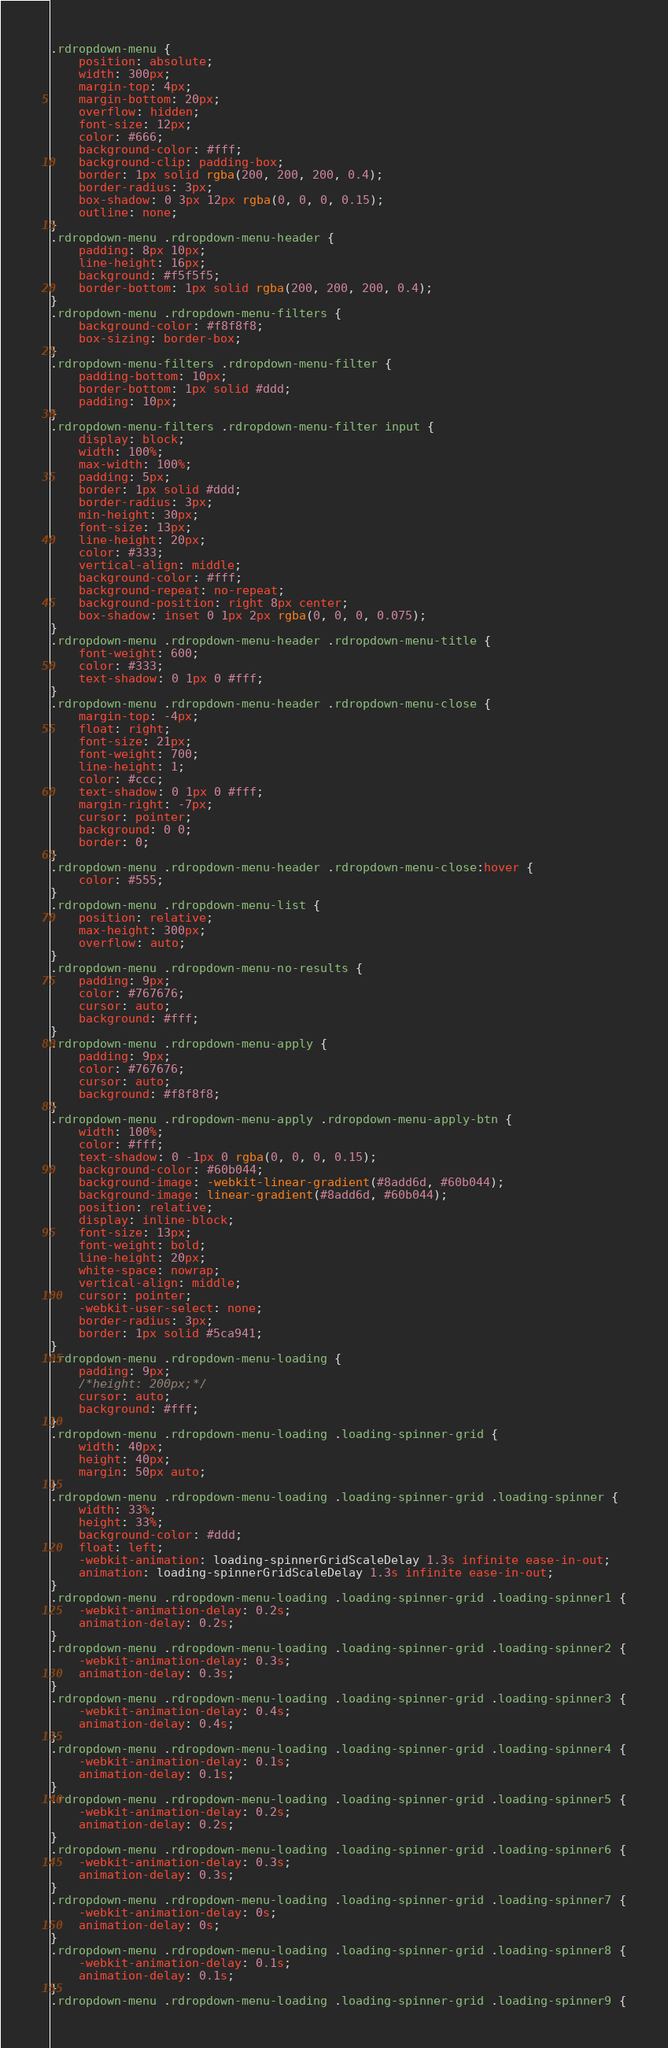Convert code to text. <code><loc_0><loc_0><loc_500><loc_500><_CSS_>.rdropdown-menu {
    position: absolute;
    width: 300px;
    margin-top: 4px;
    margin-bottom: 20px;
    overflow: hidden;
    font-size: 12px;
    color: #666;
    background-color: #fff;
    background-clip: padding-box;
    border: 1px solid rgba(200, 200, 200, 0.4);
    border-radius: 3px;
    box-shadow: 0 3px 12px rgba(0, 0, 0, 0.15);
    outline: none;
}
.rdropdown-menu .rdropdown-menu-header {
    padding: 8px 10px;
    line-height: 16px;
    background: #f5f5f5;
    border-bottom: 1px solid rgba(200, 200, 200, 0.4);
}
.rdropdown-menu .rdropdown-menu-filters {
    background-color: #f8f8f8;
    box-sizing: border-box;
}
.rdropdown-menu-filters .rdropdown-menu-filter {
    padding-bottom: 10px;
    border-bottom: 1px solid #ddd;
    padding: 10px;
}
.rdropdown-menu-filters .rdropdown-menu-filter input {
    display: block;
    width: 100%;
    max-width: 100%;
    padding: 5px;
    border: 1px solid #ddd;
    border-radius: 3px;
    min-height: 30px;
    font-size: 13px;
    line-height: 20px;
    color: #333;
    vertical-align: middle;
    background-color: #fff;
    background-repeat: no-repeat;
    background-position: right 8px center;
    box-shadow: inset 0 1px 2px rgba(0, 0, 0, 0.075);
}
.rdropdown-menu .rdropdown-menu-header .rdropdown-menu-title {
    font-weight: 600;
    color: #333;
    text-shadow: 0 1px 0 #fff;
}
.rdropdown-menu .rdropdown-menu-header .rdropdown-menu-close {
    margin-top: -4px;
    float: right;
    font-size: 21px;
    font-weight: 700;
    line-height: 1;
    color: #ccc;
    text-shadow: 0 1px 0 #fff;
    margin-right: -7px;
    cursor: pointer;
    background: 0 0;
    border: 0;
}
.rdropdown-menu .rdropdown-menu-header .rdropdown-menu-close:hover {
    color: #555;
}
.rdropdown-menu .rdropdown-menu-list {
    position: relative;
    max-height: 300px;
    overflow: auto;
}
.rdropdown-menu .rdropdown-menu-no-results {
    padding: 9px;
    color: #767676;
    cursor: auto;
    background: #fff;
}
.rdropdown-menu .rdropdown-menu-apply {
    padding: 9px;
    color: #767676;
    cursor: auto;
    background: #f8f8f8;
}
.rdropdown-menu .rdropdown-menu-apply .rdropdown-menu-apply-btn {
    width: 100%;
    color: #fff;
    text-shadow: 0 -1px 0 rgba(0, 0, 0, 0.15);
    background-color: #60b044;
    background-image: -webkit-linear-gradient(#8add6d, #60b044);
    background-image: linear-gradient(#8add6d, #60b044);
    position: relative;
    display: inline-block;
    font-size: 13px;
    font-weight: bold;
    line-height: 20px;
    white-space: nowrap;
    vertical-align: middle;
    cursor: pointer;
    -webkit-user-select: none;
    border-radius: 3px;
    border: 1px solid #5ca941;
}
.rdropdown-menu .rdropdown-menu-loading {
    padding: 9px;
    /*height: 200px;*/
    cursor: auto;
    background: #fff;
}
.rdropdown-menu .rdropdown-menu-loading .loading-spinner-grid {
    width: 40px;
    height: 40px;
    margin: 50px auto;
}
.rdropdown-menu .rdropdown-menu-loading .loading-spinner-grid .loading-spinner {
    width: 33%;
    height: 33%;
    background-color: #ddd;
    float: left;
    -webkit-animation: loading-spinnerGridScaleDelay 1.3s infinite ease-in-out;
    animation: loading-spinnerGridScaleDelay 1.3s infinite ease-in-out;
}
.rdropdown-menu .rdropdown-menu-loading .loading-spinner-grid .loading-spinner1 {
    -webkit-animation-delay: 0.2s;
    animation-delay: 0.2s;
}
.rdropdown-menu .rdropdown-menu-loading .loading-spinner-grid .loading-spinner2 {
    -webkit-animation-delay: 0.3s;
    animation-delay: 0.3s;
}
.rdropdown-menu .rdropdown-menu-loading .loading-spinner-grid .loading-spinner3 {
    -webkit-animation-delay: 0.4s;
    animation-delay: 0.4s;
}
.rdropdown-menu .rdropdown-menu-loading .loading-spinner-grid .loading-spinner4 {
    -webkit-animation-delay: 0.1s;
    animation-delay: 0.1s;
}
.rdropdown-menu .rdropdown-menu-loading .loading-spinner-grid .loading-spinner5 {
    -webkit-animation-delay: 0.2s;
    animation-delay: 0.2s;
}
.rdropdown-menu .rdropdown-menu-loading .loading-spinner-grid .loading-spinner6 {
    -webkit-animation-delay: 0.3s;
    animation-delay: 0.3s;
}
.rdropdown-menu .rdropdown-menu-loading .loading-spinner-grid .loading-spinner7 {
    -webkit-animation-delay: 0s;
    animation-delay: 0s;
}
.rdropdown-menu .rdropdown-menu-loading .loading-spinner-grid .loading-spinner8 {
    -webkit-animation-delay: 0.1s;
    animation-delay: 0.1s;
}
.rdropdown-menu .rdropdown-menu-loading .loading-spinner-grid .loading-spinner9 {</code> 